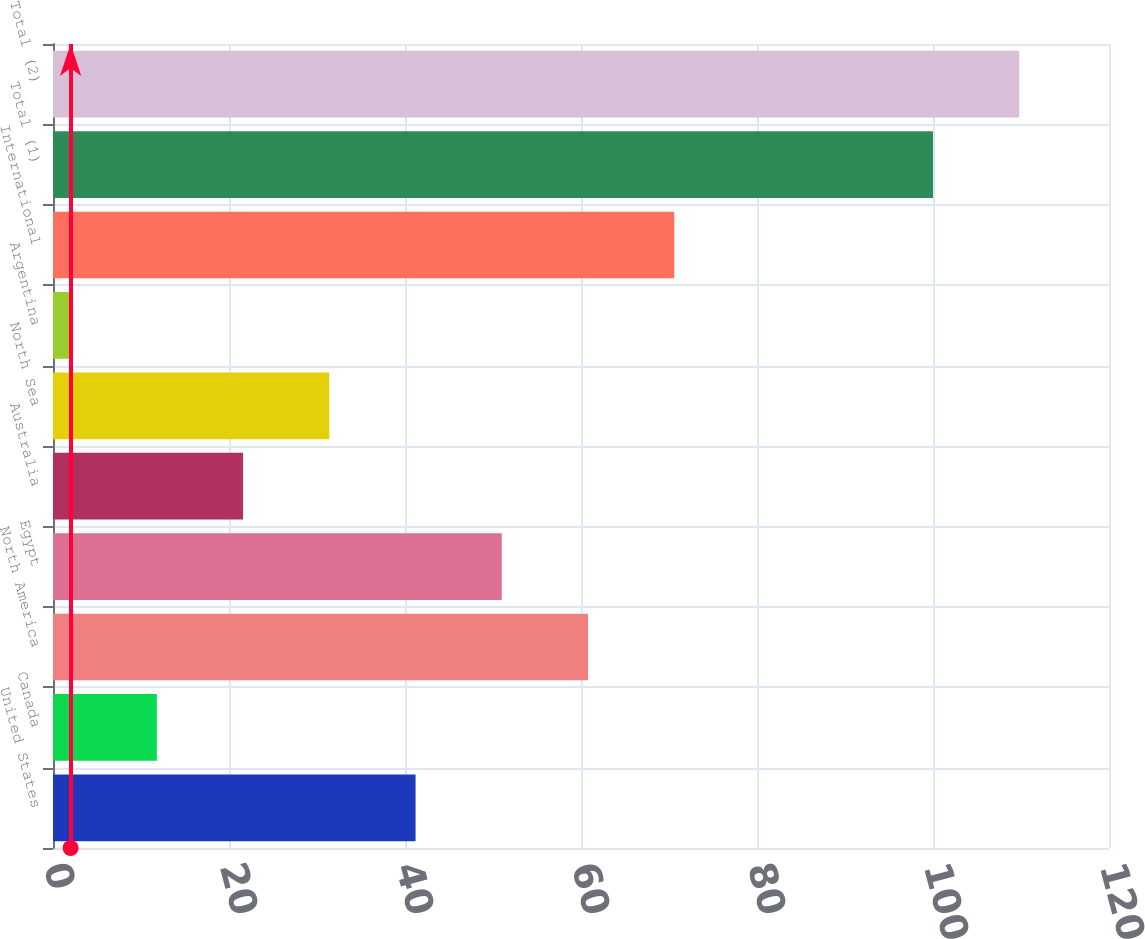<chart> <loc_0><loc_0><loc_500><loc_500><bar_chart><fcel>United States<fcel>Canada<fcel>North America<fcel>Egypt<fcel>Australia<fcel>North Sea<fcel>Argentina<fcel>International<fcel>Total (1)<fcel>Total (2)<nl><fcel>41.2<fcel>11.8<fcel>60.8<fcel>51<fcel>21.6<fcel>31.4<fcel>2<fcel>70.6<fcel>100<fcel>109.8<nl></chart> 